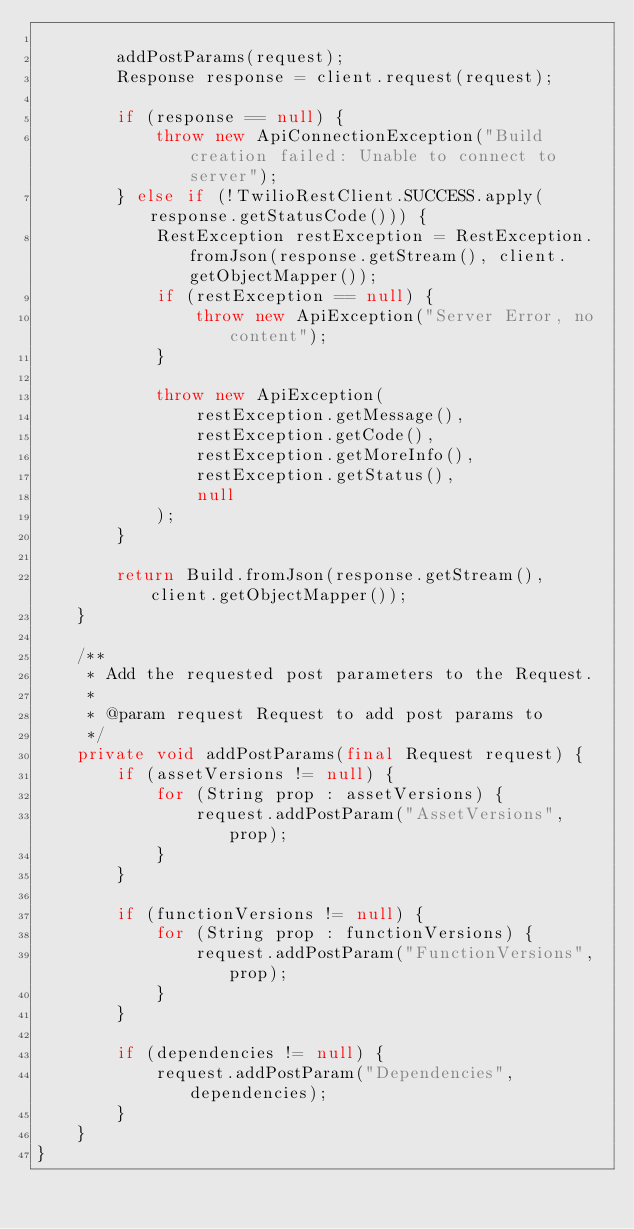Convert code to text. <code><loc_0><loc_0><loc_500><loc_500><_Java_>
        addPostParams(request);
        Response response = client.request(request);

        if (response == null) {
            throw new ApiConnectionException("Build creation failed: Unable to connect to server");
        } else if (!TwilioRestClient.SUCCESS.apply(response.getStatusCode())) {
            RestException restException = RestException.fromJson(response.getStream(), client.getObjectMapper());
            if (restException == null) {
                throw new ApiException("Server Error, no content");
            }

            throw new ApiException(
                restException.getMessage(),
                restException.getCode(),
                restException.getMoreInfo(),
                restException.getStatus(),
                null
            );
        }

        return Build.fromJson(response.getStream(), client.getObjectMapper());
    }

    /**
     * Add the requested post parameters to the Request.
     *
     * @param request Request to add post params to
     */
    private void addPostParams(final Request request) {
        if (assetVersions != null) {
            for (String prop : assetVersions) {
                request.addPostParam("AssetVersions", prop);
            }
        }

        if (functionVersions != null) {
            for (String prop : functionVersions) {
                request.addPostParam("FunctionVersions", prop);
            }
        }

        if (dependencies != null) {
            request.addPostParam("Dependencies", dependencies);
        }
    }
}</code> 